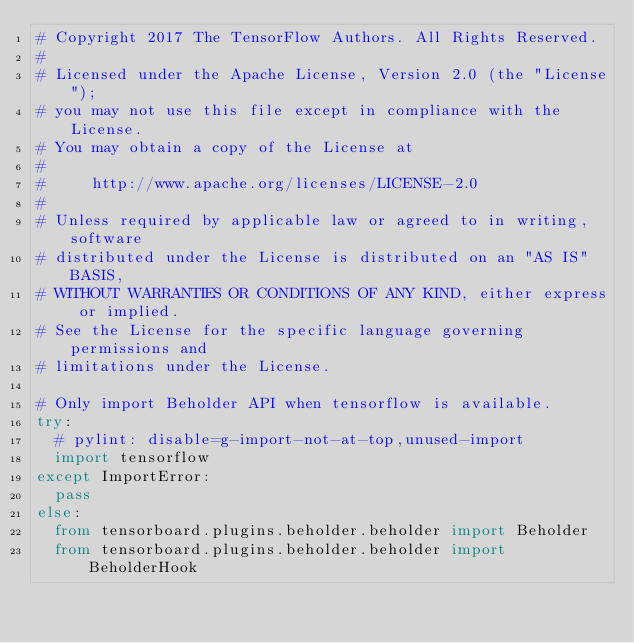Convert code to text. <code><loc_0><loc_0><loc_500><loc_500><_Python_># Copyright 2017 The TensorFlow Authors. All Rights Reserved.
#
# Licensed under the Apache License, Version 2.0 (the "License");
# you may not use this file except in compliance with the License.
# You may obtain a copy of the License at
#
#     http://www.apache.org/licenses/LICENSE-2.0
#
# Unless required by applicable law or agreed to in writing, software
# distributed under the License is distributed on an "AS IS" BASIS,
# WITHOUT WARRANTIES OR CONDITIONS OF ANY KIND, either express or implied.
# See the License for the specific language governing permissions and
# limitations under the License.

# Only import Beholder API when tensorflow is available.
try:
  # pylint: disable=g-import-not-at-top,unused-import
  import tensorflow
except ImportError:
  pass
else:
  from tensorboard.plugins.beholder.beholder import Beholder
  from tensorboard.plugins.beholder.beholder import BeholderHook
</code> 